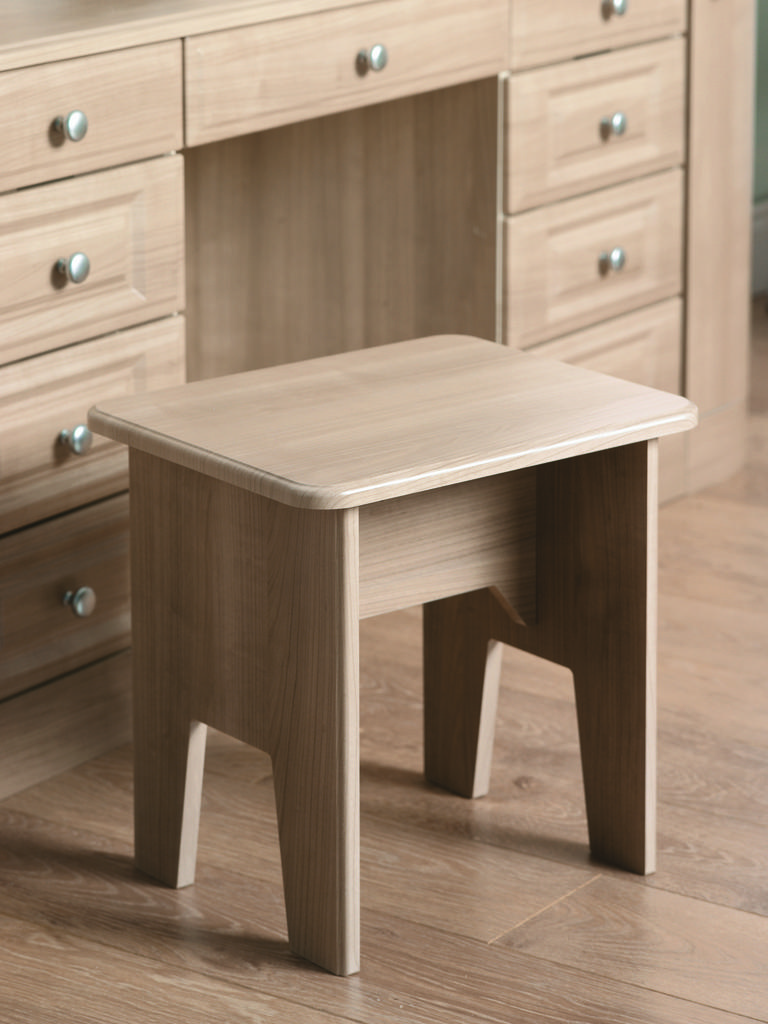What type of furniture is present in the image? There is a cupboard with drawers in the image. What is located on the floor in the image? There is a stool on the floor in the image. How many cacti are on the stool in the image? There are no cacti present in the image; it only features a cupboard with drawers and a stool on the floor. What type of paper is visible on the cupboard in the image? There is no paper visible on the cupboard in the image. 